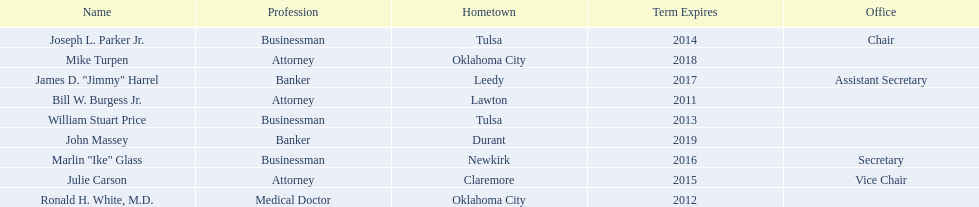What is the total amount of current state regents who are bankers? 2. 